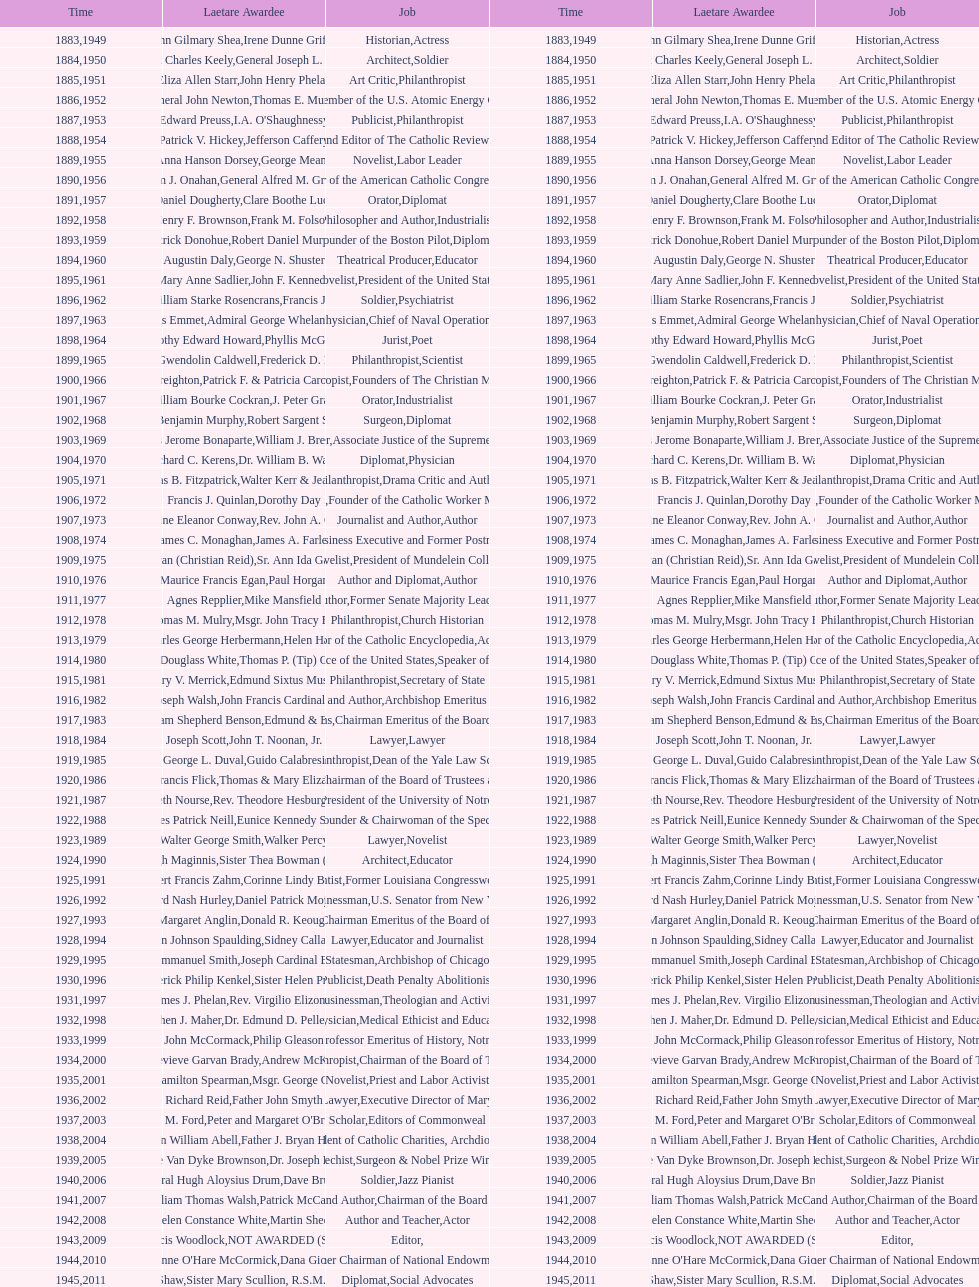Who was the previous winner before john henry phelan in 1951? General Joseph L. Collins. 